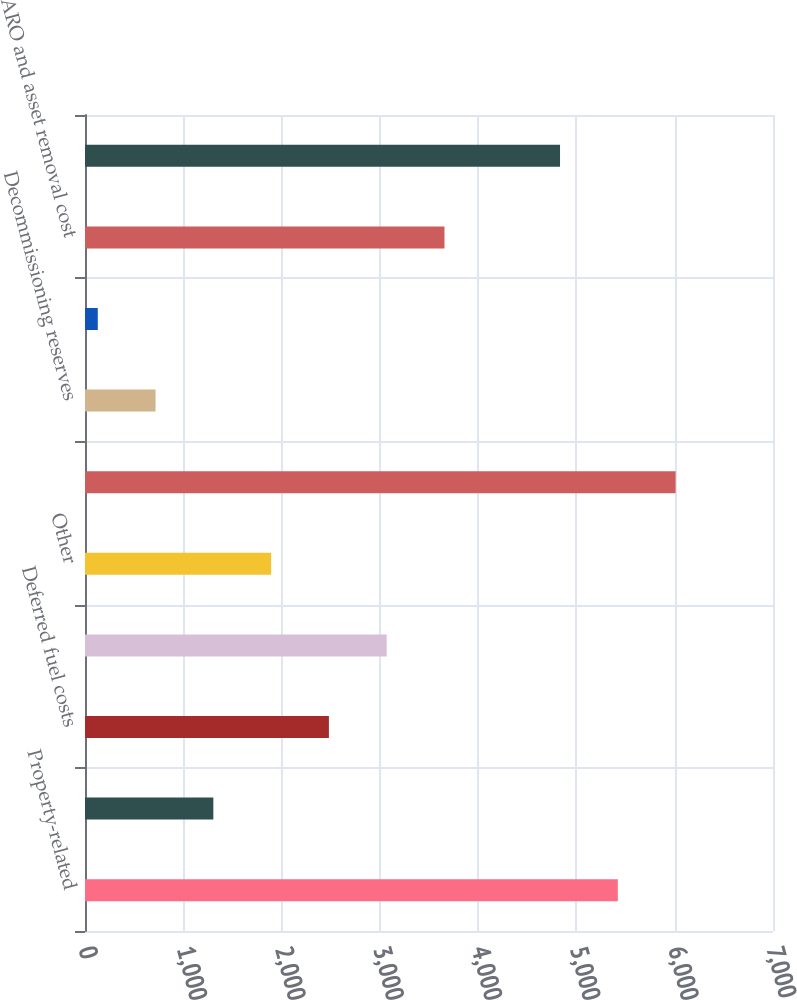Convert chart. <chart><loc_0><loc_0><loc_500><loc_500><bar_chart><fcel>Property-related<fcel>Pension<fcel>Deferred fuel costs<fcel>Storm reserve deficiency<fcel>Other<fcel>Total deferred tax liabilities<fcel>Decommissioning reserves<fcel>Postretirement benefits<fcel>ARO and asset removal cost<fcel>Net deferred tax assets<nl><fcel>5421.1<fcel>1305.8<fcel>2481.6<fcel>3069.5<fcel>1893.7<fcel>6009<fcel>717.9<fcel>130<fcel>3657.4<fcel>4833.2<nl></chart> 